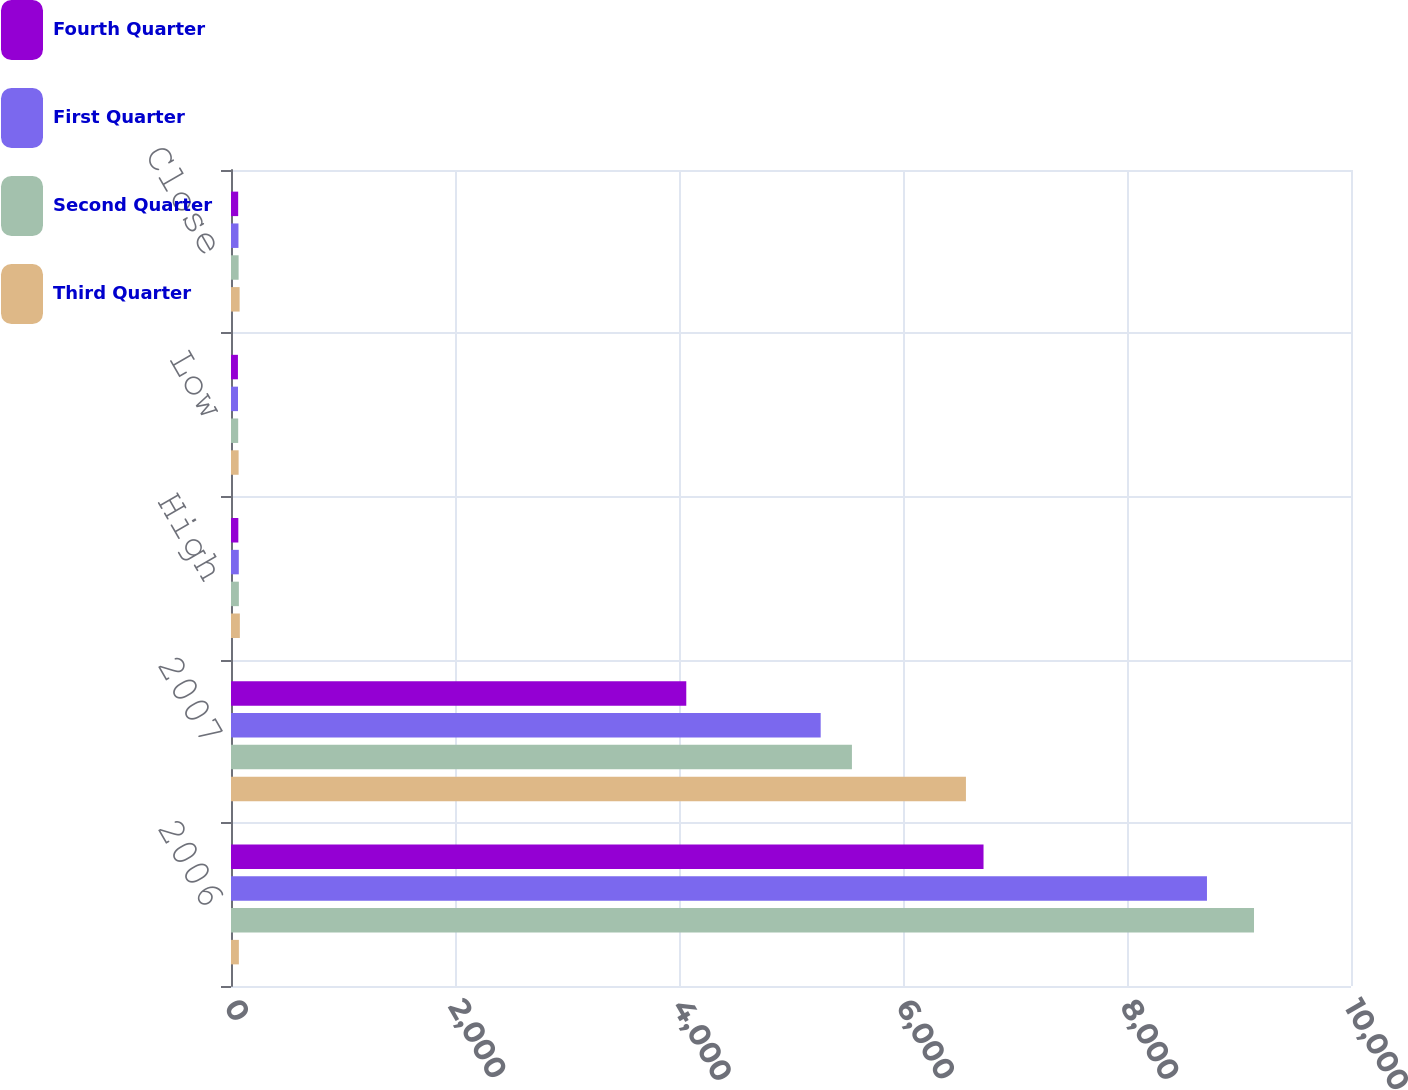Convert chart. <chart><loc_0><loc_0><loc_500><loc_500><stacked_bar_chart><ecel><fcel>2006<fcel>2007<fcel>High<fcel>Low<fcel>Close<nl><fcel>Fourth Quarter<fcel>6719<fcel>4065<fcel>65.54<fcel>61.89<fcel>64.09<nl><fcel>First Quarter<fcel>8714<fcel>5265<fcel>69.64<fcel>62.57<fcel>66.68<nl><fcel>Second Quarter<fcel>9134<fcel>5544<fcel>70.25<fcel>64.25<fcel>67.98<nl><fcel>Third Quarter<fcel>70.25<fcel>6562<fcel>79<fcel>68.02<fcel>77.03<nl></chart> 